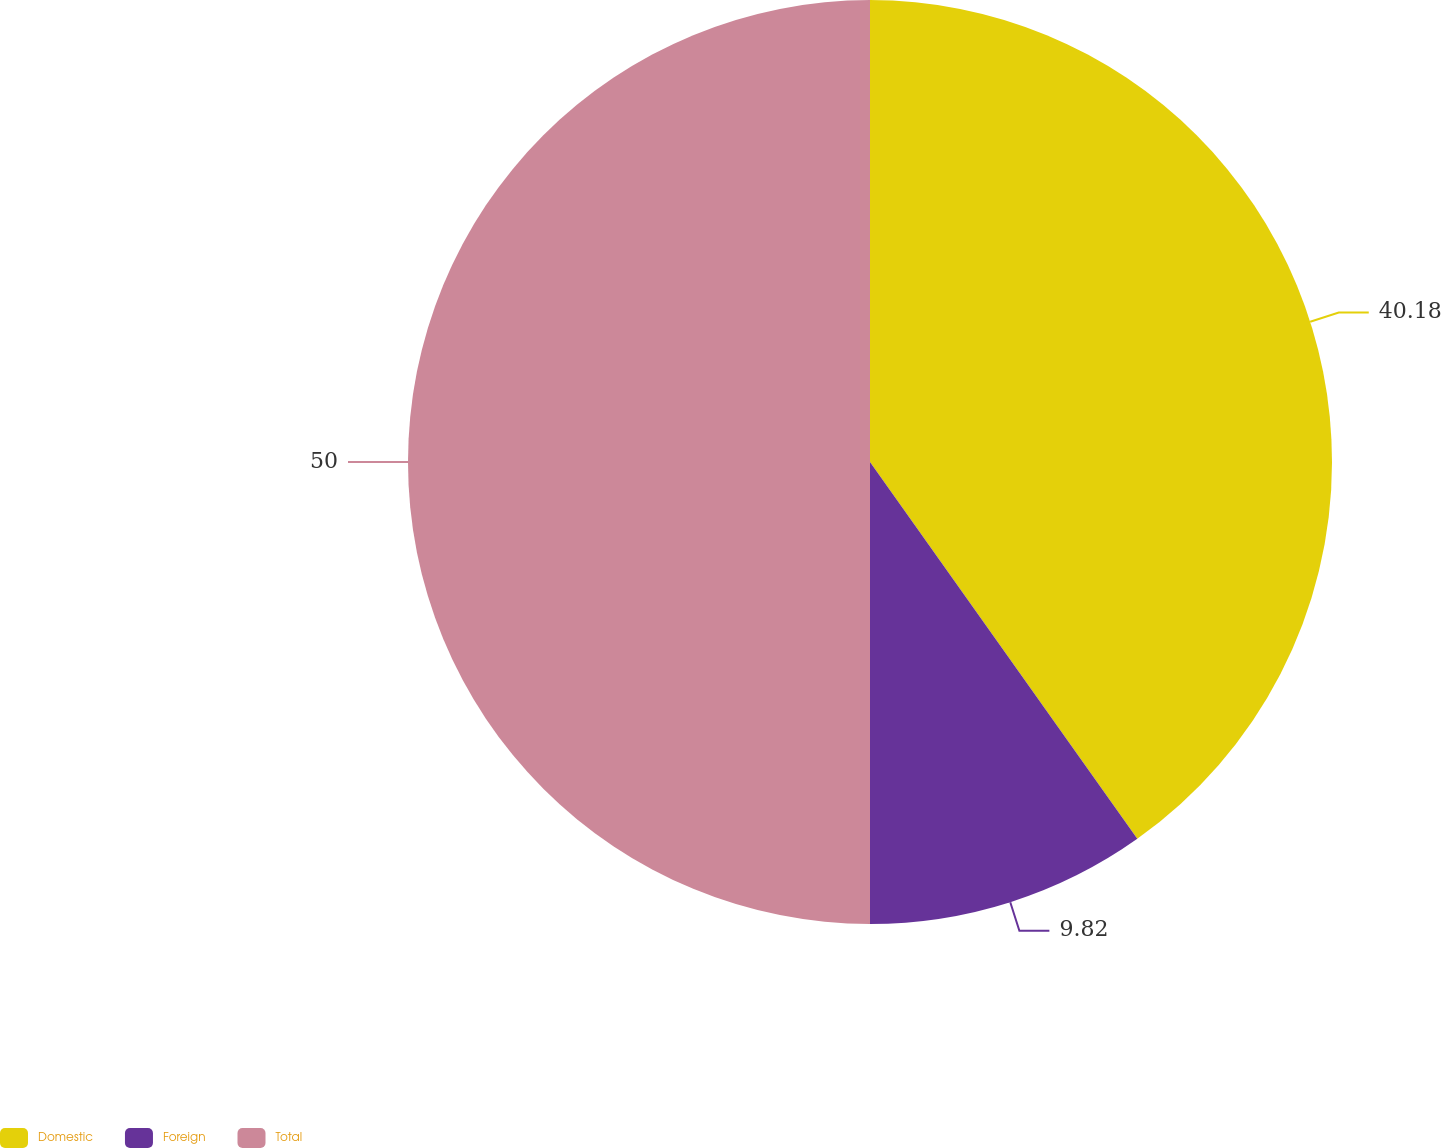Convert chart. <chart><loc_0><loc_0><loc_500><loc_500><pie_chart><fcel>Domestic<fcel>Foreign<fcel>Total<nl><fcel>40.18%<fcel>9.82%<fcel>50.0%<nl></chart> 